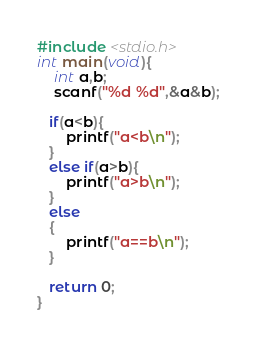<code> <loc_0><loc_0><loc_500><loc_500><_C_>#include <stdio.h>
int main(void){
    int a,b;
    scanf("%d %d",&a&b);
  
   if(a<b){
       printf("a<b\n");
   }
   else if(a>b){
       printf("a>b\n");
   }
   else 
   {
       printf("a==b\n");
   }
   
   return 0;
}</code> 